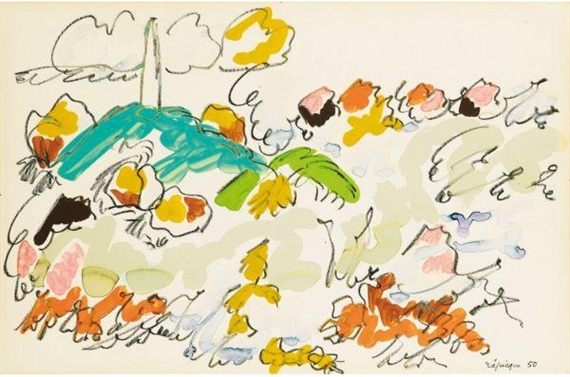What emotions do you think this abstract art piece evokes? This abstract art piece evokes a sense of joy and creativity through its vibrant colors and dynamic forms. The use of bright yellows, blues, and greens conveys an uplifting and lively atmosphere, while the fluid, free-flowing lines suggest spontaneity and freedom. Viewers might feel a playful sense of wonder, as the abstract elements encourage personal interpretation and emotional engagement. How would you imagine a day in the world depicted in this artwork? A day in the world of this artwork would be like stepping into a whimsy-filled paradise. Imagine waking up to a sunlit sky dotted with gray clouds, wandering through lush gardens of fantastically colored flowers and plants. The air would be filled with the melody of birds, their vibrant blue feathers shimmering in the light. You might discover enchanted palm trees swaying gently, each frond a different shade of green. Every step would reveal something new and unexpected, inviting you to explore and delight in the abstract beauty that surrounds you. 